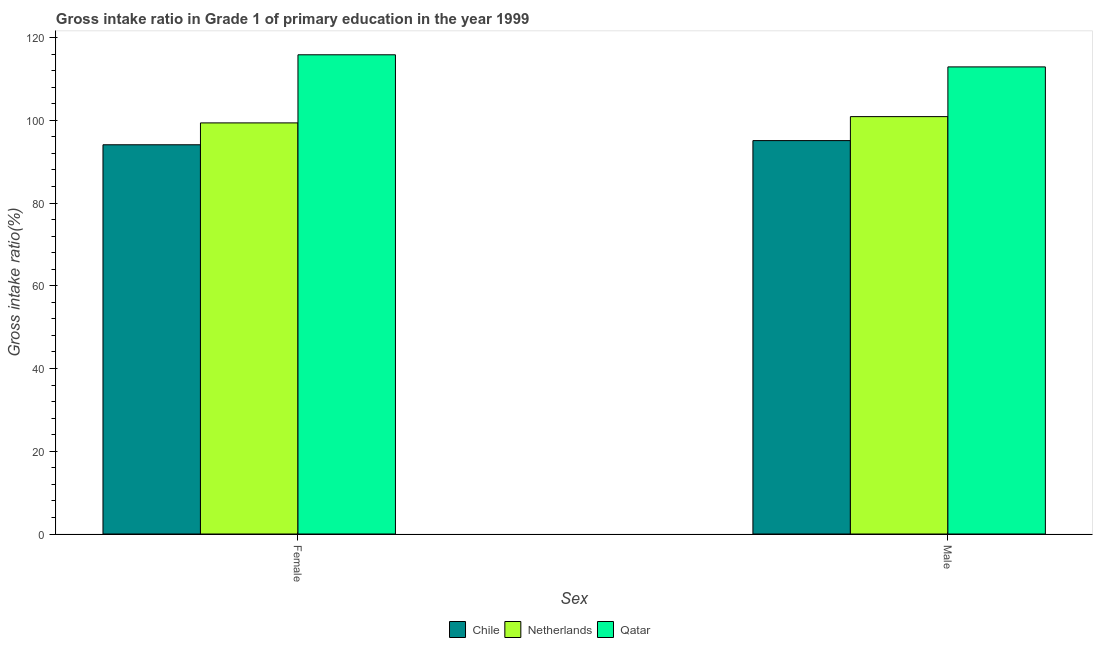Are the number of bars per tick equal to the number of legend labels?
Offer a very short reply. Yes. Are the number of bars on each tick of the X-axis equal?
Your answer should be compact. Yes. How many bars are there on the 2nd tick from the left?
Provide a short and direct response. 3. How many bars are there on the 2nd tick from the right?
Your response must be concise. 3. What is the label of the 2nd group of bars from the left?
Your answer should be compact. Male. What is the gross intake ratio(male) in Netherlands?
Provide a succinct answer. 100.89. Across all countries, what is the maximum gross intake ratio(female)?
Your answer should be very brief. 115.83. Across all countries, what is the minimum gross intake ratio(male)?
Offer a terse response. 95.09. In which country was the gross intake ratio(female) maximum?
Ensure brevity in your answer.  Qatar. What is the total gross intake ratio(female) in the graph?
Provide a short and direct response. 309.28. What is the difference between the gross intake ratio(male) in Qatar and that in Netherlands?
Your answer should be very brief. 12.02. What is the difference between the gross intake ratio(female) in Chile and the gross intake ratio(male) in Netherlands?
Offer a terse response. -6.8. What is the average gross intake ratio(male) per country?
Make the answer very short. 102.96. What is the difference between the gross intake ratio(female) and gross intake ratio(male) in Qatar?
Keep it short and to the point. 2.93. In how many countries, is the gross intake ratio(female) greater than 8 %?
Make the answer very short. 3. What is the ratio of the gross intake ratio(female) in Netherlands to that in Chile?
Your answer should be very brief. 1.06. Is the gross intake ratio(female) in Qatar less than that in Chile?
Give a very brief answer. No. In how many countries, is the gross intake ratio(female) greater than the average gross intake ratio(female) taken over all countries?
Offer a very short reply. 1. What does the 2nd bar from the left in Male represents?
Keep it short and to the point. Netherlands. What does the 2nd bar from the right in Male represents?
Ensure brevity in your answer.  Netherlands. How many bars are there?
Provide a short and direct response. 6. Are all the bars in the graph horizontal?
Give a very brief answer. No. What is the difference between two consecutive major ticks on the Y-axis?
Give a very brief answer. 20. Are the values on the major ticks of Y-axis written in scientific E-notation?
Your answer should be very brief. No. Where does the legend appear in the graph?
Your answer should be compact. Bottom center. How are the legend labels stacked?
Give a very brief answer. Horizontal. What is the title of the graph?
Provide a succinct answer. Gross intake ratio in Grade 1 of primary education in the year 1999. Does "Malta" appear as one of the legend labels in the graph?
Your answer should be compact. No. What is the label or title of the X-axis?
Provide a short and direct response. Sex. What is the label or title of the Y-axis?
Your answer should be very brief. Gross intake ratio(%). What is the Gross intake ratio(%) of Chile in Female?
Provide a short and direct response. 94.08. What is the Gross intake ratio(%) in Netherlands in Female?
Your answer should be compact. 99.37. What is the Gross intake ratio(%) of Qatar in Female?
Provide a succinct answer. 115.83. What is the Gross intake ratio(%) in Chile in Male?
Your answer should be very brief. 95.09. What is the Gross intake ratio(%) in Netherlands in Male?
Provide a short and direct response. 100.89. What is the Gross intake ratio(%) of Qatar in Male?
Your response must be concise. 112.9. Across all Sex, what is the maximum Gross intake ratio(%) in Chile?
Give a very brief answer. 95.09. Across all Sex, what is the maximum Gross intake ratio(%) of Netherlands?
Provide a succinct answer. 100.89. Across all Sex, what is the maximum Gross intake ratio(%) of Qatar?
Make the answer very short. 115.83. Across all Sex, what is the minimum Gross intake ratio(%) of Chile?
Your answer should be very brief. 94.08. Across all Sex, what is the minimum Gross intake ratio(%) of Netherlands?
Keep it short and to the point. 99.37. Across all Sex, what is the minimum Gross intake ratio(%) of Qatar?
Make the answer very short. 112.9. What is the total Gross intake ratio(%) of Chile in the graph?
Your answer should be compact. 189.17. What is the total Gross intake ratio(%) in Netherlands in the graph?
Your response must be concise. 200.25. What is the total Gross intake ratio(%) in Qatar in the graph?
Ensure brevity in your answer.  228.73. What is the difference between the Gross intake ratio(%) in Chile in Female and that in Male?
Offer a terse response. -1.01. What is the difference between the Gross intake ratio(%) in Netherlands in Female and that in Male?
Your answer should be compact. -1.52. What is the difference between the Gross intake ratio(%) of Qatar in Female and that in Male?
Offer a terse response. 2.93. What is the difference between the Gross intake ratio(%) of Chile in Female and the Gross intake ratio(%) of Netherlands in Male?
Ensure brevity in your answer.  -6.8. What is the difference between the Gross intake ratio(%) of Chile in Female and the Gross intake ratio(%) of Qatar in Male?
Keep it short and to the point. -18.82. What is the difference between the Gross intake ratio(%) of Netherlands in Female and the Gross intake ratio(%) of Qatar in Male?
Offer a very short reply. -13.54. What is the average Gross intake ratio(%) in Chile per Sex?
Your answer should be compact. 94.59. What is the average Gross intake ratio(%) in Netherlands per Sex?
Provide a succinct answer. 100.13. What is the average Gross intake ratio(%) in Qatar per Sex?
Make the answer very short. 114.37. What is the difference between the Gross intake ratio(%) in Chile and Gross intake ratio(%) in Netherlands in Female?
Your answer should be very brief. -5.29. What is the difference between the Gross intake ratio(%) of Chile and Gross intake ratio(%) of Qatar in Female?
Make the answer very short. -21.75. What is the difference between the Gross intake ratio(%) in Netherlands and Gross intake ratio(%) in Qatar in Female?
Your answer should be compact. -16.46. What is the difference between the Gross intake ratio(%) of Chile and Gross intake ratio(%) of Netherlands in Male?
Provide a succinct answer. -5.8. What is the difference between the Gross intake ratio(%) in Chile and Gross intake ratio(%) in Qatar in Male?
Offer a very short reply. -17.81. What is the difference between the Gross intake ratio(%) of Netherlands and Gross intake ratio(%) of Qatar in Male?
Offer a terse response. -12.02. What is the ratio of the Gross intake ratio(%) in Chile in Female to that in Male?
Ensure brevity in your answer.  0.99. What is the ratio of the Gross intake ratio(%) in Netherlands in Female to that in Male?
Offer a very short reply. 0.98. What is the ratio of the Gross intake ratio(%) in Qatar in Female to that in Male?
Give a very brief answer. 1.03. What is the difference between the highest and the second highest Gross intake ratio(%) of Chile?
Ensure brevity in your answer.  1.01. What is the difference between the highest and the second highest Gross intake ratio(%) in Netherlands?
Provide a succinct answer. 1.52. What is the difference between the highest and the second highest Gross intake ratio(%) of Qatar?
Offer a very short reply. 2.93. What is the difference between the highest and the lowest Gross intake ratio(%) in Chile?
Make the answer very short. 1.01. What is the difference between the highest and the lowest Gross intake ratio(%) of Netherlands?
Offer a terse response. 1.52. What is the difference between the highest and the lowest Gross intake ratio(%) of Qatar?
Provide a short and direct response. 2.93. 